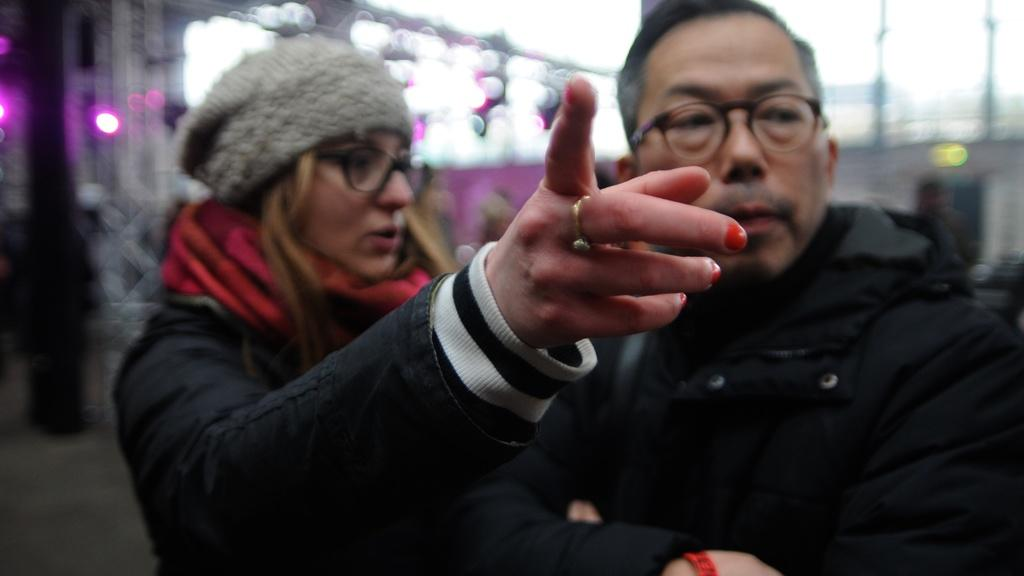How many people are in the foreground of the image? There are two persons in the foreground of the image. What can be seen in the background of the image? There are lights in the background of the image. What is the income of the pet in the image? There is no pet present in the image, so it is not possible to determine its income. 